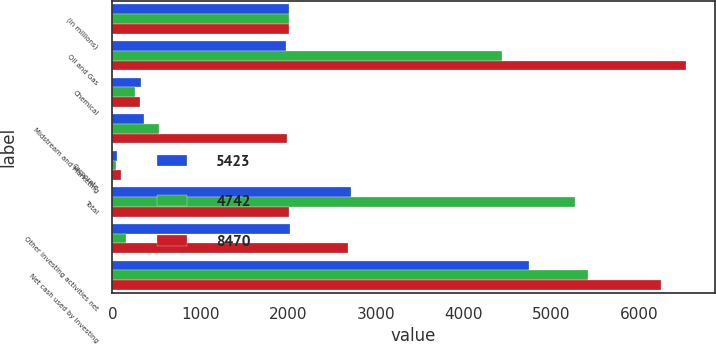Convert chart to OTSL. <chart><loc_0><loc_0><loc_500><loc_500><stacked_bar_chart><ecel><fcel>(in millions)<fcel>Oil and Gas<fcel>Chemical<fcel>Midstream and Marketing<fcel>Corporate<fcel>Total<fcel>Other investing activities net<fcel>Net cash used by investing<nl><fcel>5423<fcel>2016<fcel>1978<fcel>324<fcel>358<fcel>57<fcel>2717<fcel>2025<fcel>4742<nl><fcel>4742<fcel>2015<fcel>4442<fcel>254<fcel>535<fcel>41<fcel>5272<fcel>151<fcel>5423<nl><fcel>8470<fcel>2014<fcel>6533<fcel>314<fcel>1983<fcel>100<fcel>2014<fcel>2686<fcel>6244<nl></chart> 